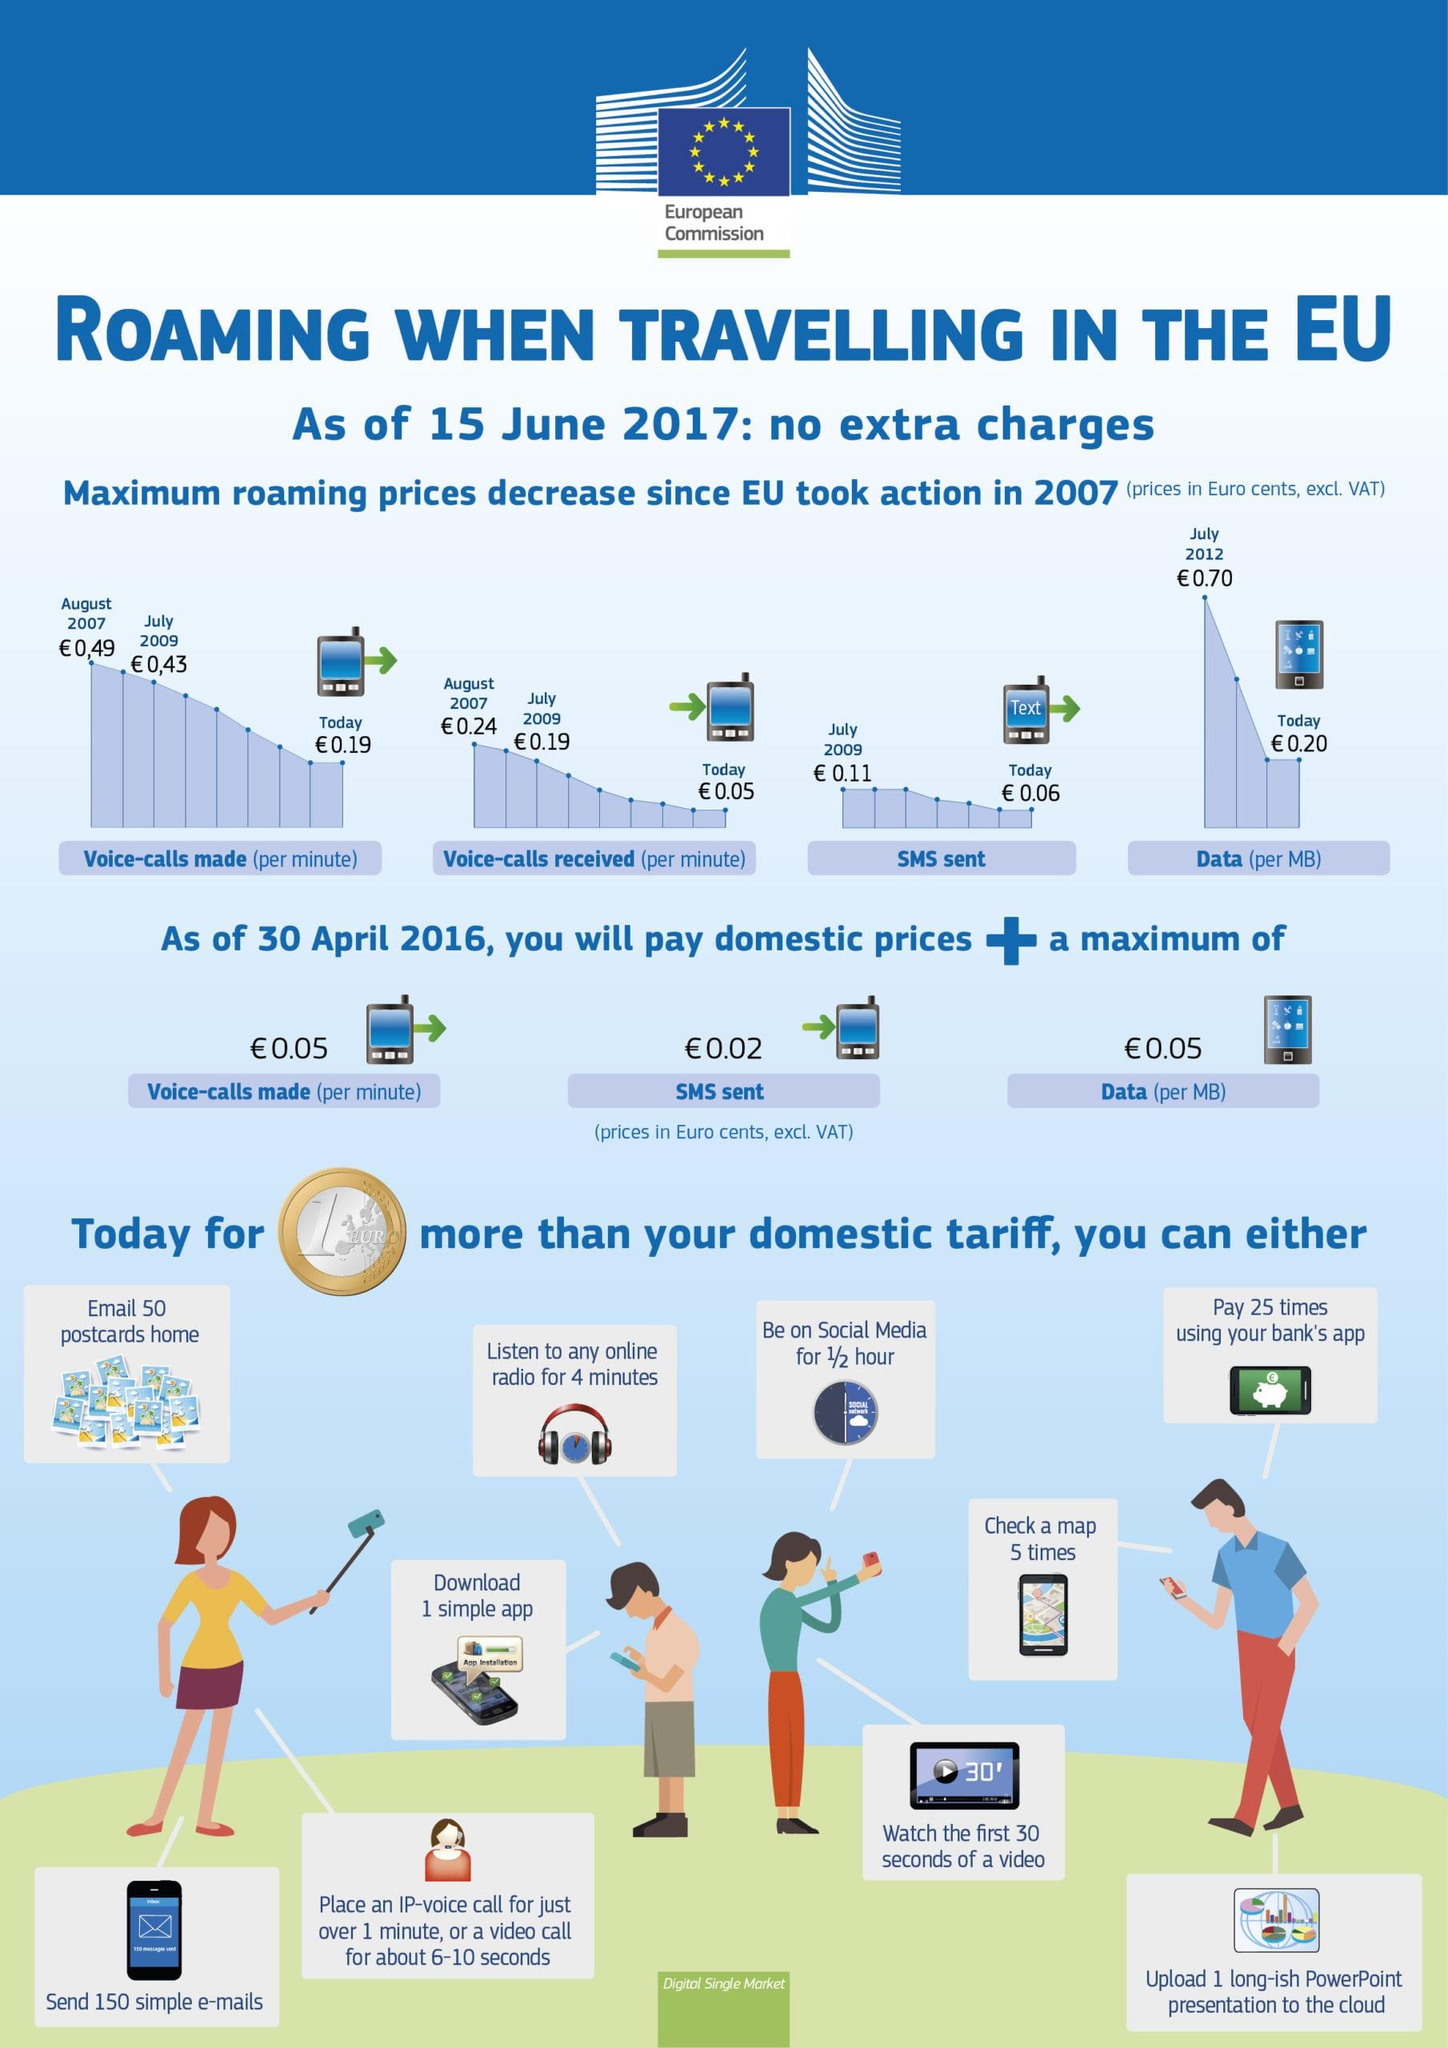Specify some key components in this picture. The amount written on the coin is 1 euro. As of April 30, 2016, an additional 0.02 cents would need to be paid for each SMS sent. For an additional 1 euro, domestic users can spend up to 30 minutes on social media. It is possible to download one simple app for an additional 1 euro on a domestic tariff, as compared to the standard rate. For 1 euro more than the domestic tariff, you can listen to online radio for 4 minutes. 